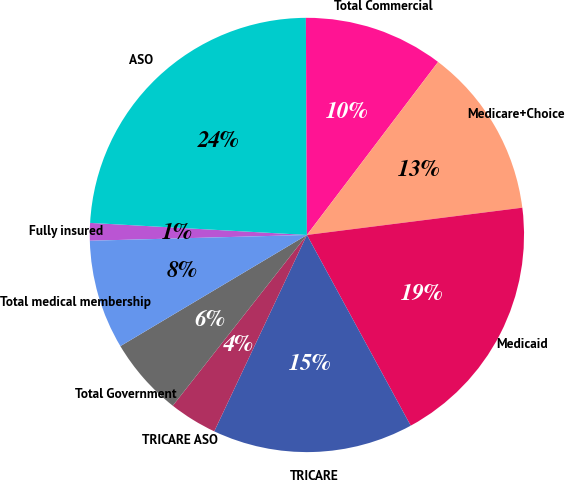Convert chart to OTSL. <chart><loc_0><loc_0><loc_500><loc_500><pie_chart><fcel>Fully insured<fcel>ASO<fcel>Total Commercial<fcel>Medicare+Choice<fcel>Medicaid<fcel>TRICARE<fcel>TRICARE ASO<fcel>Total Government<fcel>Total medical membership<nl><fcel>1.31%<fcel>24.04%<fcel>10.4%<fcel>12.67%<fcel>19.07%<fcel>14.95%<fcel>3.58%<fcel>5.85%<fcel>8.13%<nl></chart> 